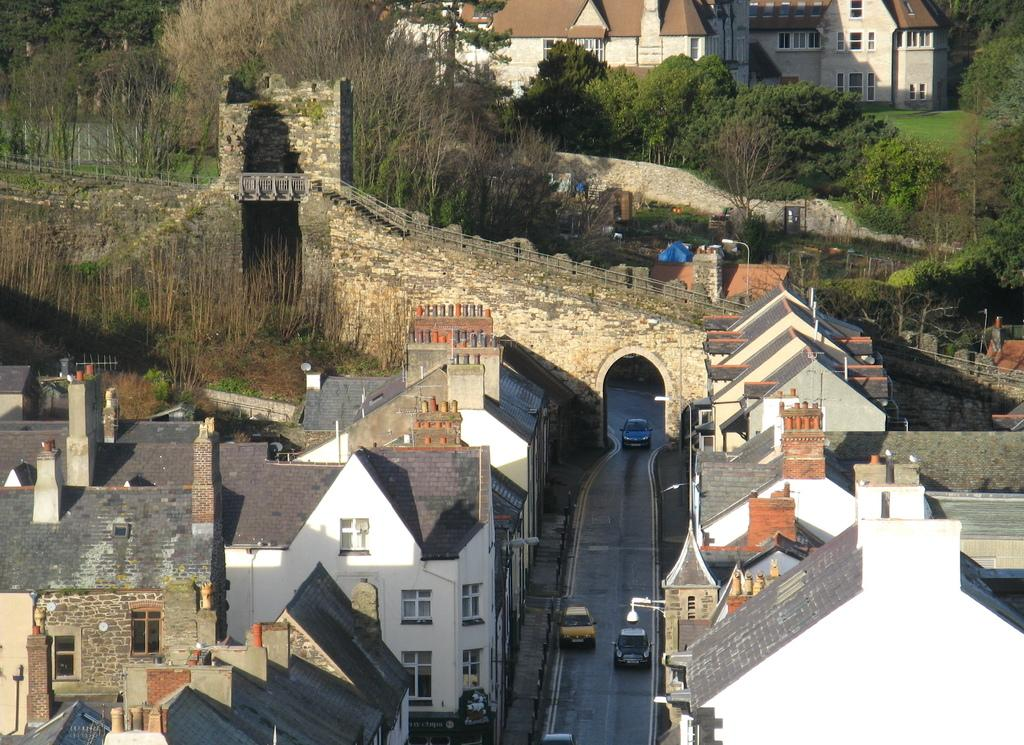What type of structures can be seen in the image? There are buildings in the image. What is happening on the road in the image? Vehicles are present on the road in the image. What architectural feature is present in the image? There is a bridge in the image. What type of barrier is visible in the image? A fence is visible in the image. What type of vegetation is present in the image? Grass and trees are visible in the image. What time of day was the image likely taken? The image was likely taken during the day. What type of stew is being served on the bridge in the image? There is no stew present in the image; the image features a bridge, buildings, vehicles, a fence, grass, and trees. What type of net is being used to catch fish in the image? There is no net or fishing activity present in the image. 